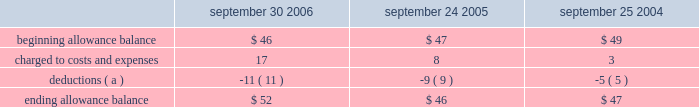Notes to consolidated financial statements ( continued ) note 3 2014financial instruments ( continued ) accounts receivable trade receivables the company distributes its products through third-party distributors and resellers and directly to certain education , consumer , and commercial customers .
The company generally does not require collateral from its customers ; however , the company will require collateral in certain instances to limit credit risk .
In addition , when possible , the company does attempt to limit credit risk on trade receivables with credit insurance for certain customers in latin america , europe , asia , and australia and by arranging with third- party financing companies to provide flooring arrangements and other loan and lease programs to the company 2019s direct customers .
These credit-financing arrangements are directly between the third-party financing company and the end customer .
As such , the company generally does not assume any recourse or credit risk sharing related to any of these arrangements .
However , considerable trade receivables that are not covered by collateral , third-party flooring arrangements , or credit insurance are outstanding with the company 2019s distribution and retail channel partners .
No customer accounted for more than 10% ( 10 % ) of trade receivables as of september 30 , 2006 or september 24 , 2005 .
The table summarizes the activity in the allowance for doubtful accounts ( in millions ) : september 30 , september 24 , september 25 .
( a ) represents amounts written off against the allowance , net of recoveries .
Vendor non-trade receivables the company has non-trade receivables from certain of its manufacturing vendors resulting from the sale of raw material components to these manufacturing vendors who manufacture sub-assemblies or assemble final products for the company .
The company purchases these raw material components directly from suppliers .
These non-trade receivables , which are included in the consolidated balance sheets in other current assets , totaled $ 1.6 billion and $ 417 million as of september 30 , 2006 and september 24 , 2005 , respectively .
The company does not reflect the sale of these components in net sales and does not recognize any profits on these sales until the products are sold through to the end customer at which time the profit is recognized as a reduction of cost of sales .
Derivative financial instruments the company uses derivatives to partially offset its business exposure to foreign exchange risk .
Foreign currency forward and option contracts are used to offset the foreign exchange risk on certain existing assets and liabilities and to hedge the foreign exchange risk on expected future cash flows on certain forecasted revenue and cost of sales .
From time to time , the company enters into interest rate derivative agreements to modify the interest rate profile of certain investments and debt .
The company 2019s accounting policies for these instruments are based on whether the instruments are designated as hedge or non-hedge instruments .
The company records all derivatives on the balance sheet at fair value. .
What was the greatest beginning allowance balance , in millions? 
Computations: table_max(beginning allowance balance, none)
Answer: 49.0. 